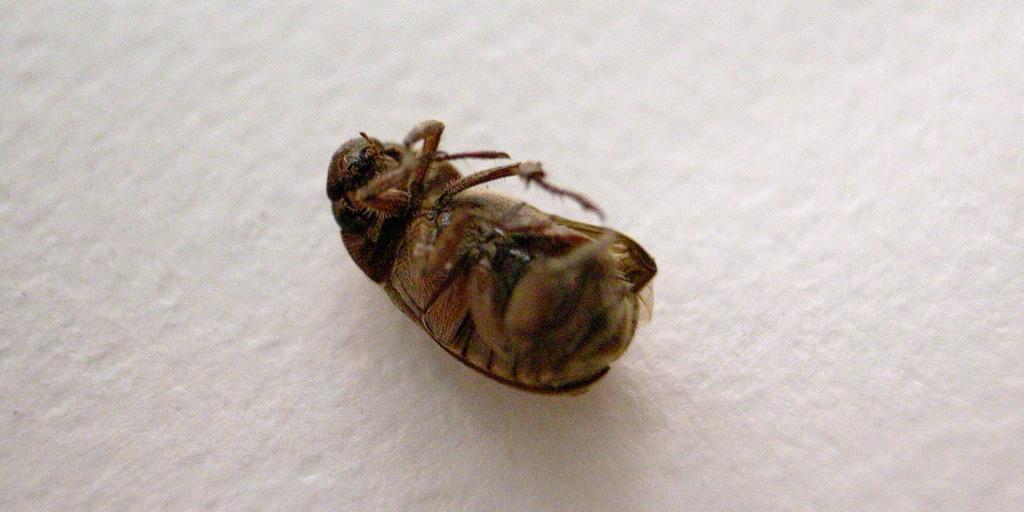Please provide a concise description of this image. In this picture we can see a cockroach on a white background. 